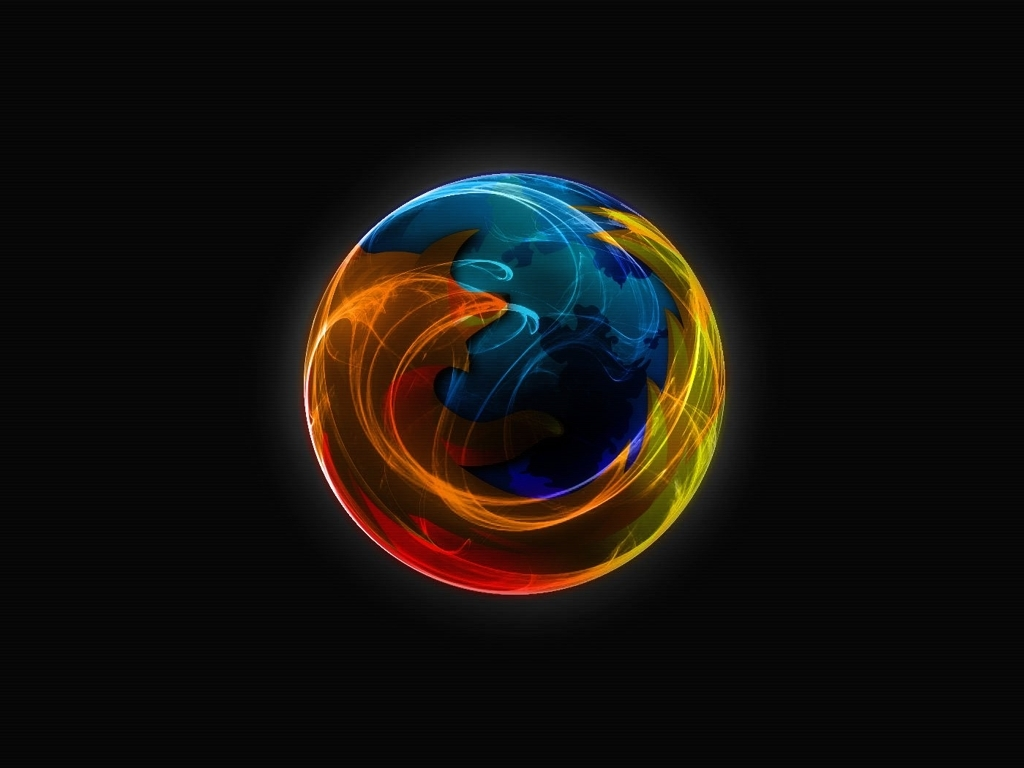How might this image be used in a commercial context? Commercially, this image could be used as a striking background for advertisements, a visual element in multimedia presentations, or as part of branding materials for businesses aiming to convey innovation, energy, and cutting-edge technology. 